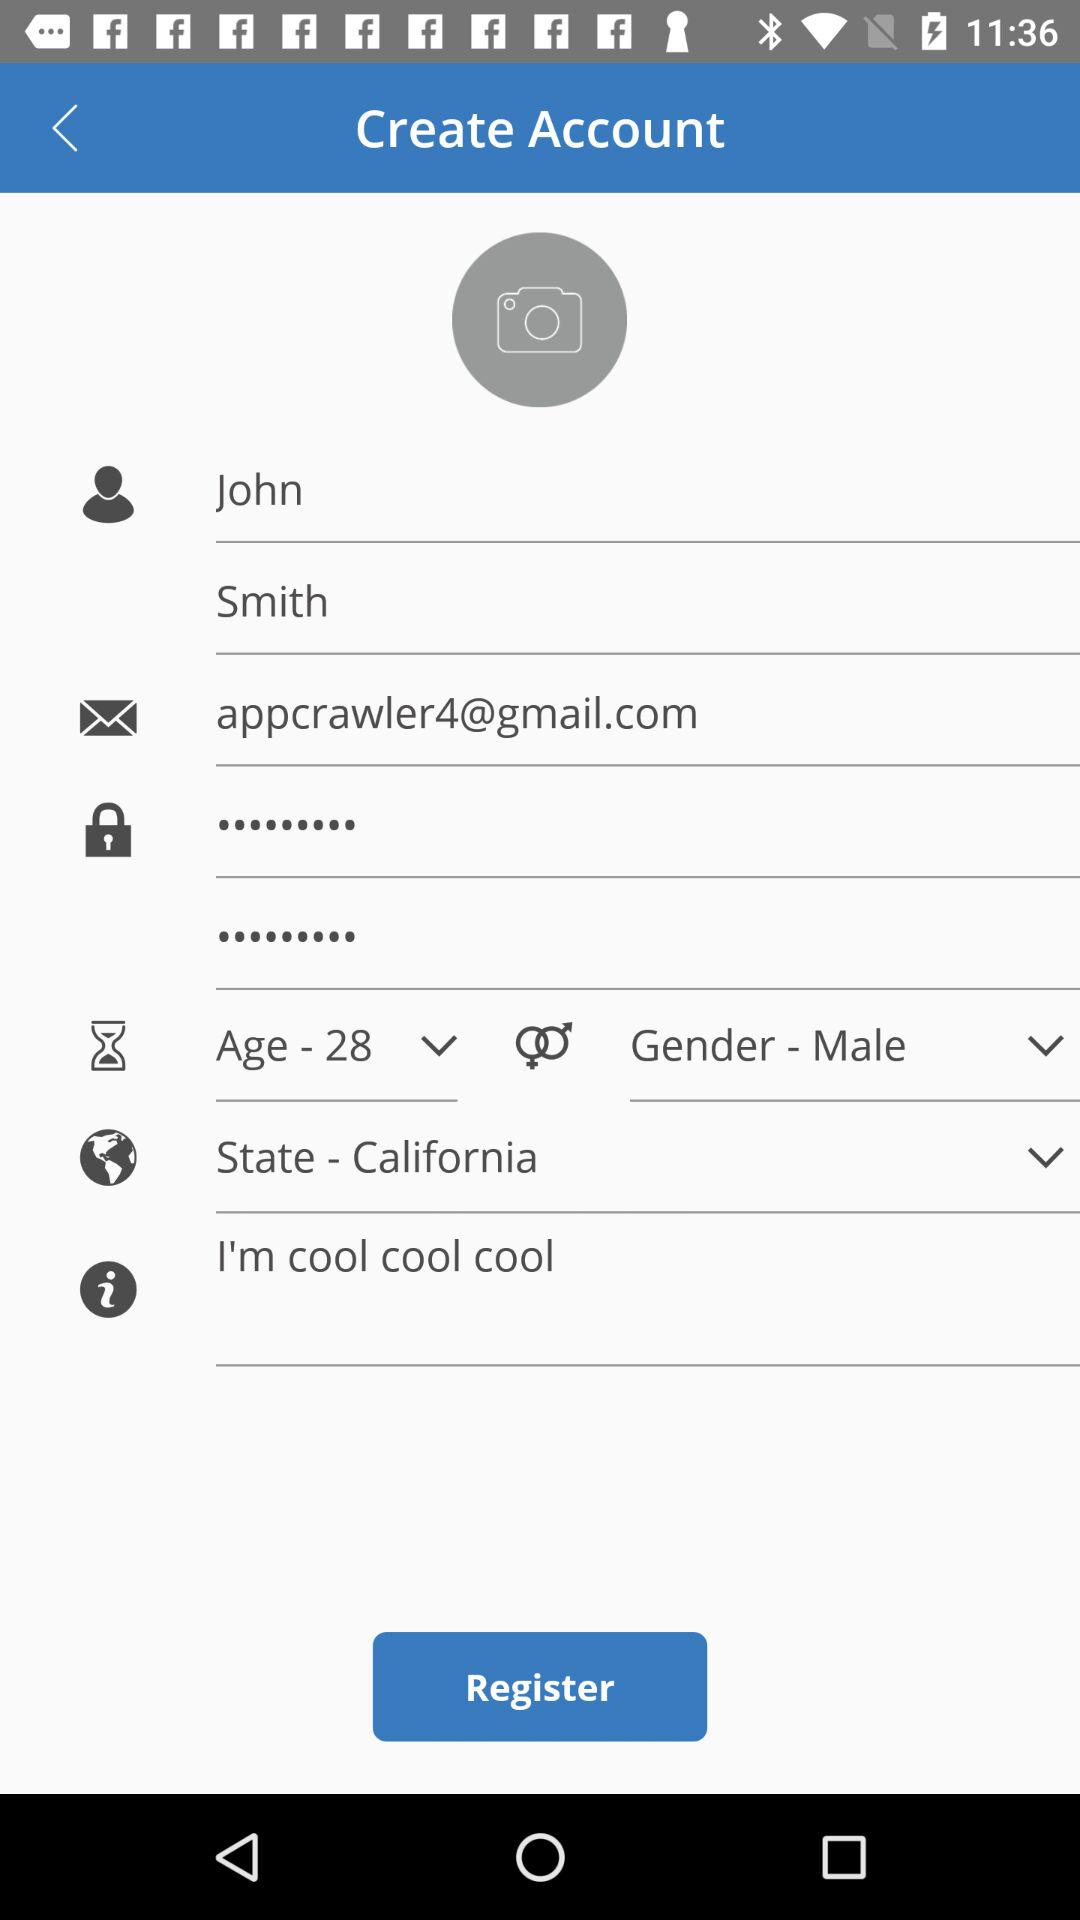What is the current location? The current location is California. 